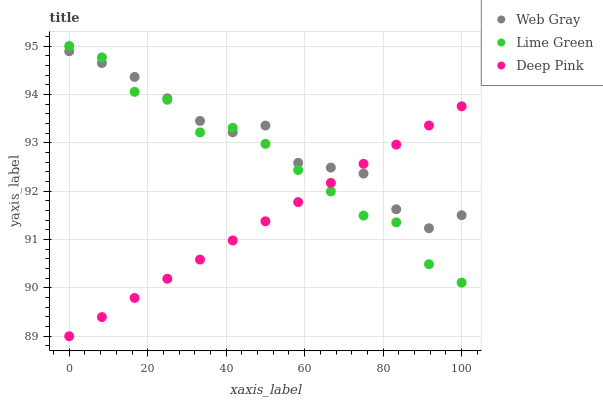Does Deep Pink have the minimum area under the curve?
Answer yes or no. Yes. Does Web Gray have the maximum area under the curve?
Answer yes or no. Yes. Does Lime Green have the minimum area under the curve?
Answer yes or no. No. Does Lime Green have the maximum area under the curve?
Answer yes or no. No. Is Deep Pink the smoothest?
Answer yes or no. Yes. Is Lime Green the roughest?
Answer yes or no. Yes. Is Lime Green the smoothest?
Answer yes or no. No. Is Deep Pink the roughest?
Answer yes or no. No. Does Deep Pink have the lowest value?
Answer yes or no. Yes. Does Lime Green have the lowest value?
Answer yes or no. No. Does Lime Green have the highest value?
Answer yes or no. Yes. Does Deep Pink have the highest value?
Answer yes or no. No. Does Web Gray intersect Deep Pink?
Answer yes or no. Yes. Is Web Gray less than Deep Pink?
Answer yes or no. No. Is Web Gray greater than Deep Pink?
Answer yes or no. No. 